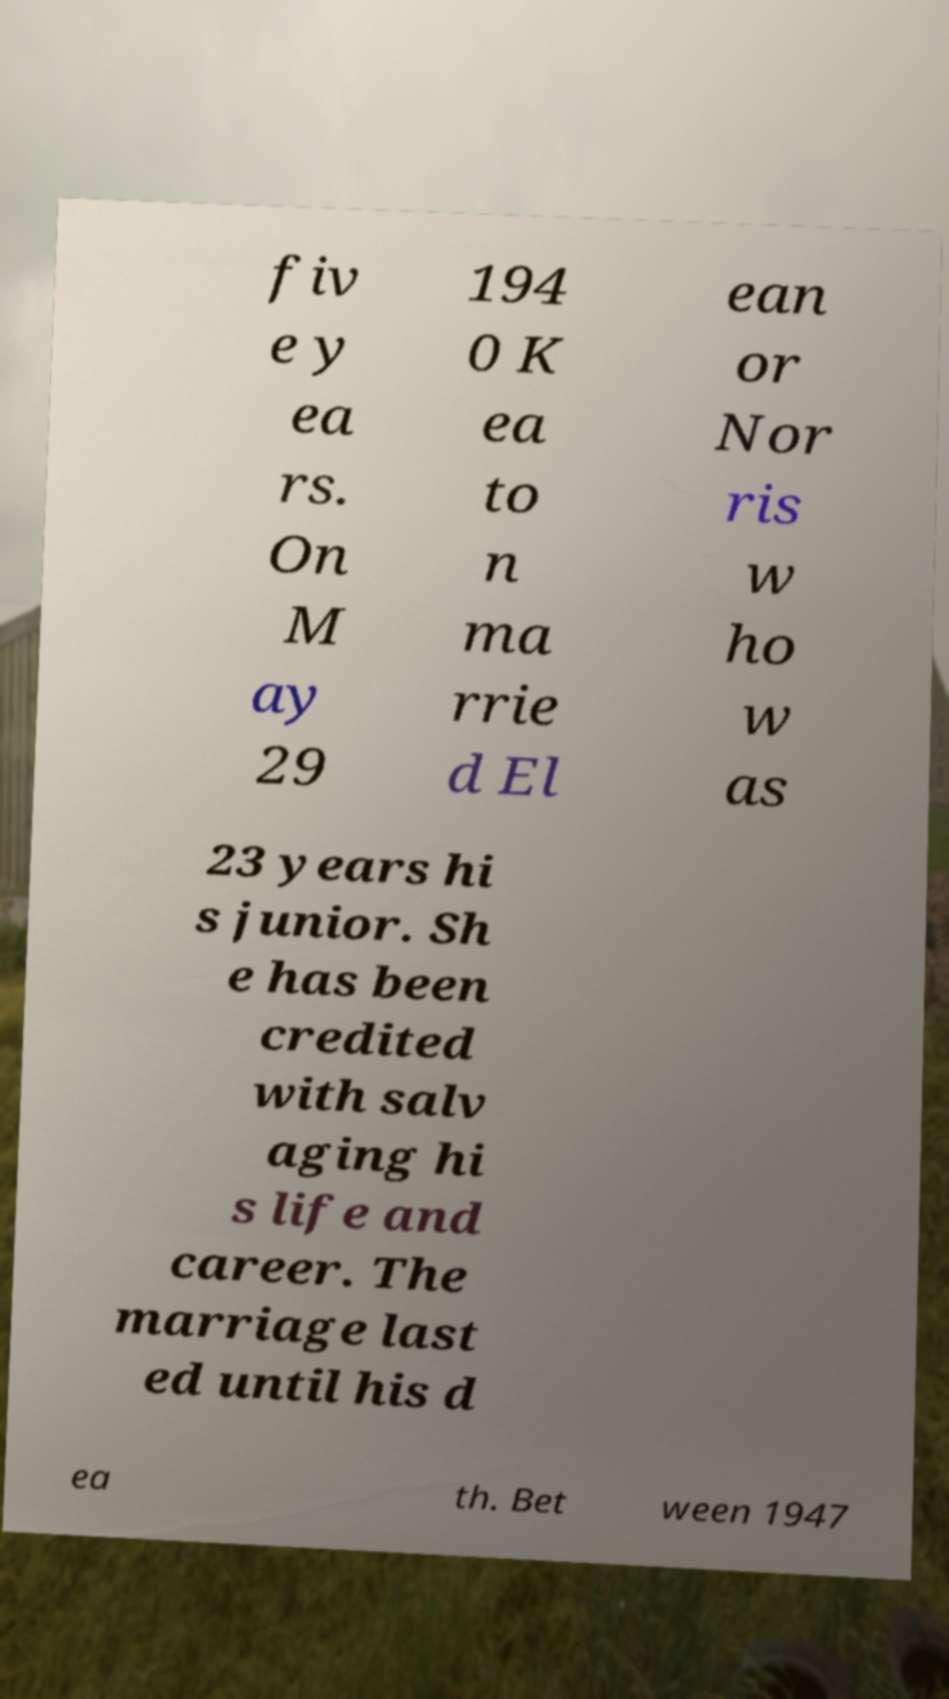There's text embedded in this image that I need extracted. Can you transcribe it verbatim? fiv e y ea rs. On M ay 29 194 0 K ea to n ma rrie d El ean or Nor ris w ho w as 23 years hi s junior. Sh e has been credited with salv aging hi s life and career. The marriage last ed until his d ea th. Bet ween 1947 